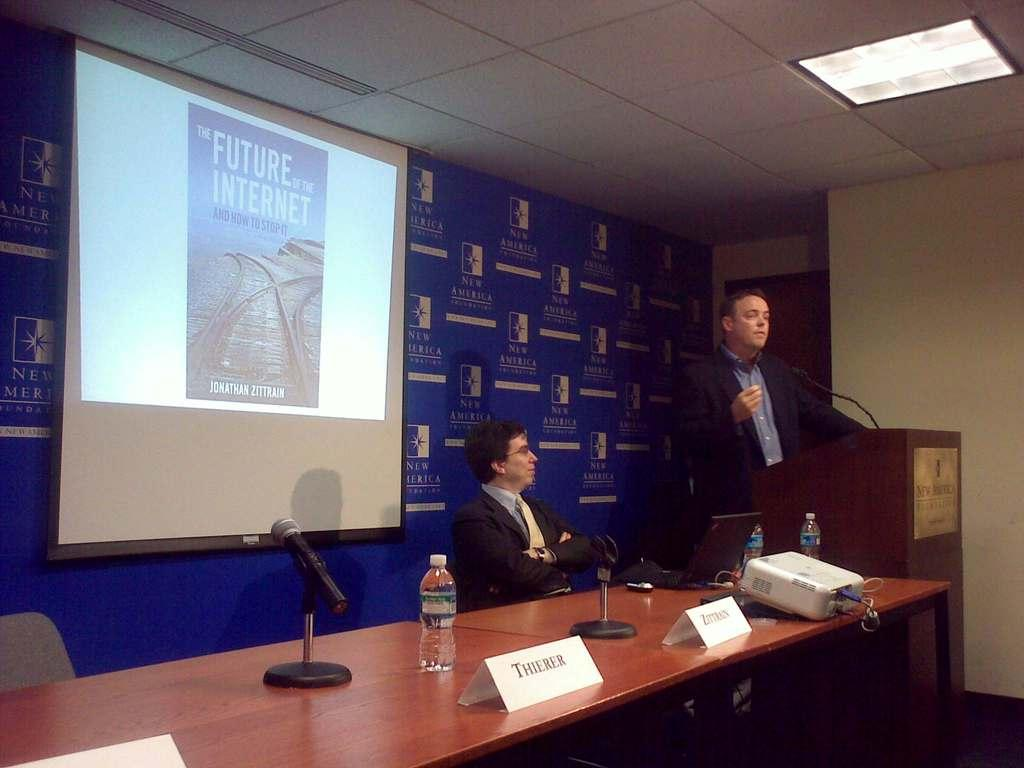<image>
Render a clear and concise summary of the photo. A book about stopping the internet is being shown on the screen. 